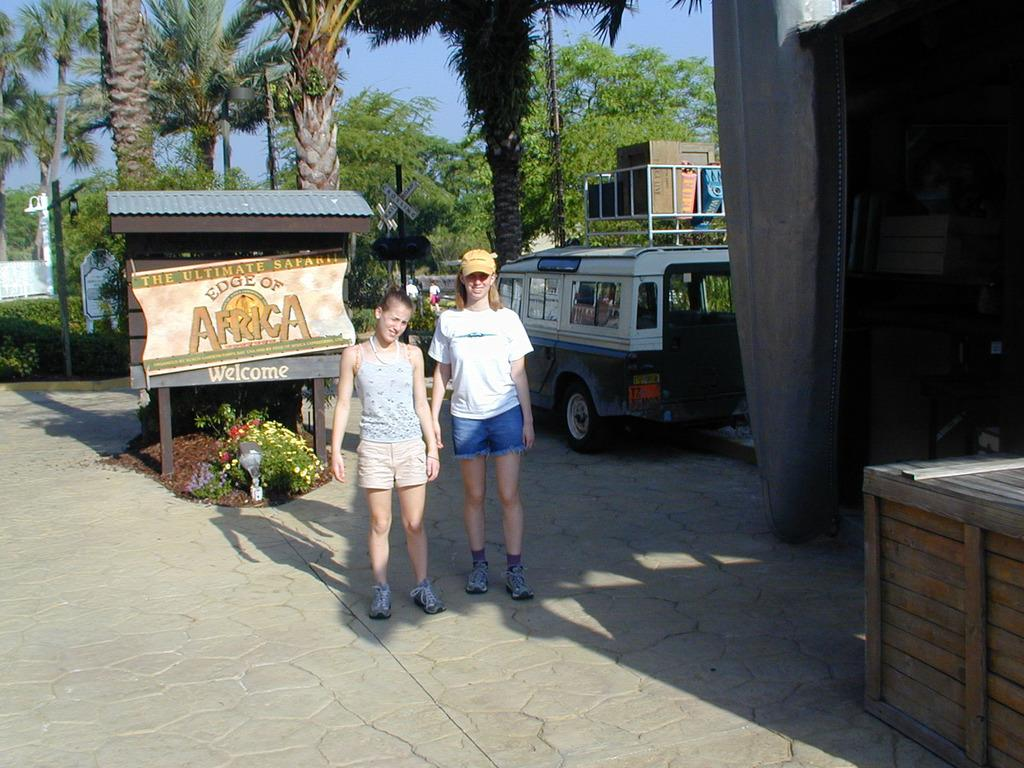<image>
Render a clear and concise summary of the photo. Two people standing in front of a sign which says Africa. 